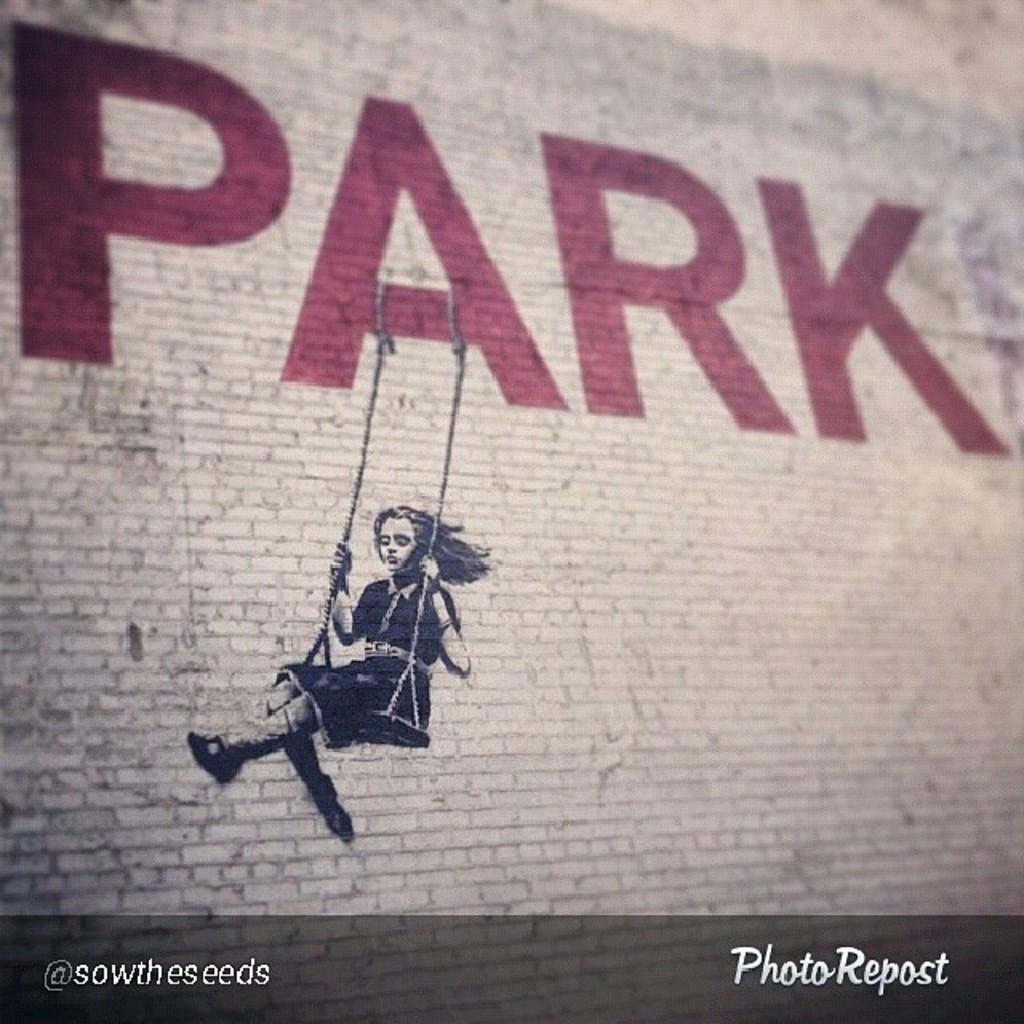What is the main subject of the image? There is an art piece in the image. Can you describe any additional features of the art piece? Unfortunately, the provided facts do not give any specific details about the art piece. What is written or displayed at the bottom of the image? There is text at the bottom of the image. What type of vest is the art piece wearing in the image? There is no vest or any clothing present in the image, as it features an art piece and text. 